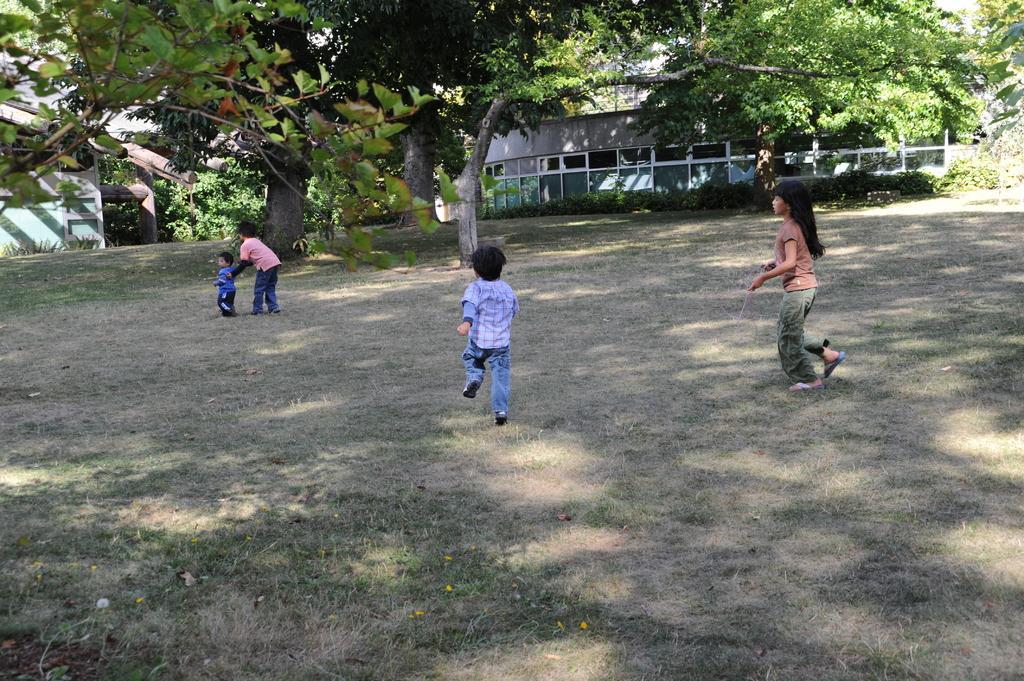Please provide a concise description of this image. In the center of the image, we can see kids and in the background, there are buildings, trees. At the bottom, there is ground. 